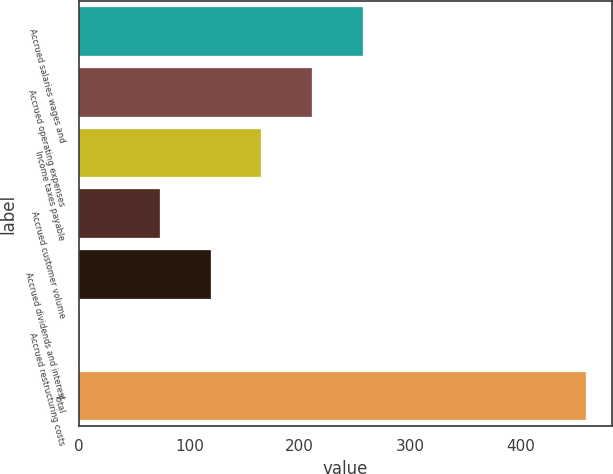<chart> <loc_0><loc_0><loc_500><loc_500><bar_chart><fcel>Accrued salaries wages and<fcel>Accrued operating expenses<fcel>Income taxes payable<fcel>Accrued customer volume<fcel>Accrued dividends and interest<fcel>Accrued restructuring costs<fcel>Total<nl><fcel>257<fcel>211.1<fcel>165.2<fcel>73.4<fcel>119.3<fcel>0.8<fcel>459.8<nl></chart> 